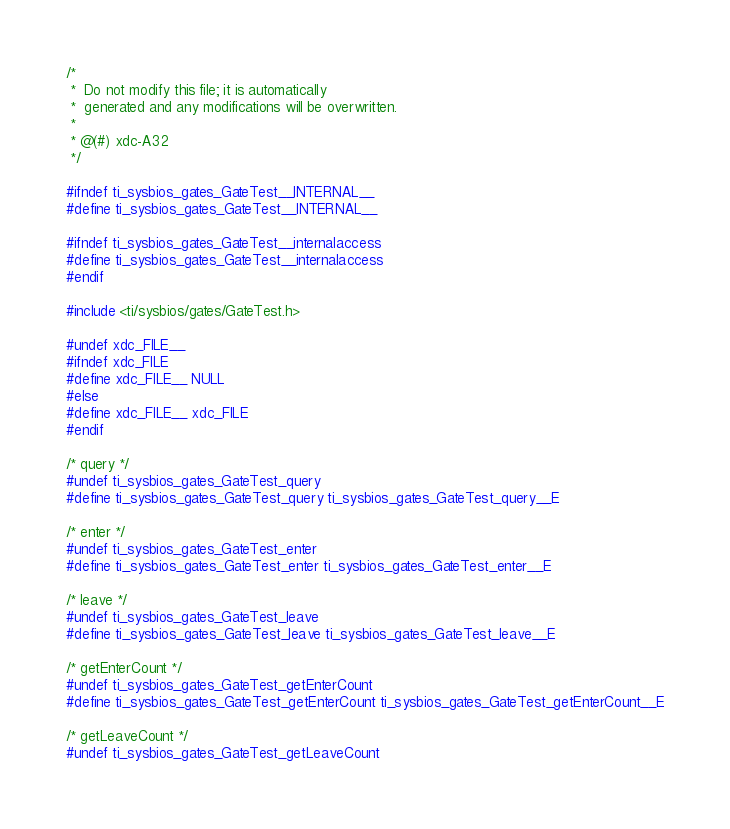Convert code to text. <code><loc_0><loc_0><loc_500><loc_500><_C_>/*
 *  Do not modify this file; it is automatically 
 *  generated and any modifications will be overwritten.
 *
 * @(#) xdc-A32
 */

#ifndef ti_sysbios_gates_GateTest__INTERNAL__
#define ti_sysbios_gates_GateTest__INTERNAL__

#ifndef ti_sysbios_gates_GateTest__internalaccess
#define ti_sysbios_gates_GateTest__internalaccess
#endif

#include <ti/sysbios/gates/GateTest.h>

#undef xdc_FILE__
#ifndef xdc_FILE
#define xdc_FILE__ NULL
#else
#define xdc_FILE__ xdc_FILE
#endif

/* query */
#undef ti_sysbios_gates_GateTest_query
#define ti_sysbios_gates_GateTest_query ti_sysbios_gates_GateTest_query__E

/* enter */
#undef ti_sysbios_gates_GateTest_enter
#define ti_sysbios_gates_GateTest_enter ti_sysbios_gates_GateTest_enter__E

/* leave */
#undef ti_sysbios_gates_GateTest_leave
#define ti_sysbios_gates_GateTest_leave ti_sysbios_gates_GateTest_leave__E

/* getEnterCount */
#undef ti_sysbios_gates_GateTest_getEnterCount
#define ti_sysbios_gates_GateTest_getEnterCount ti_sysbios_gates_GateTest_getEnterCount__E

/* getLeaveCount */
#undef ti_sysbios_gates_GateTest_getLeaveCount</code> 